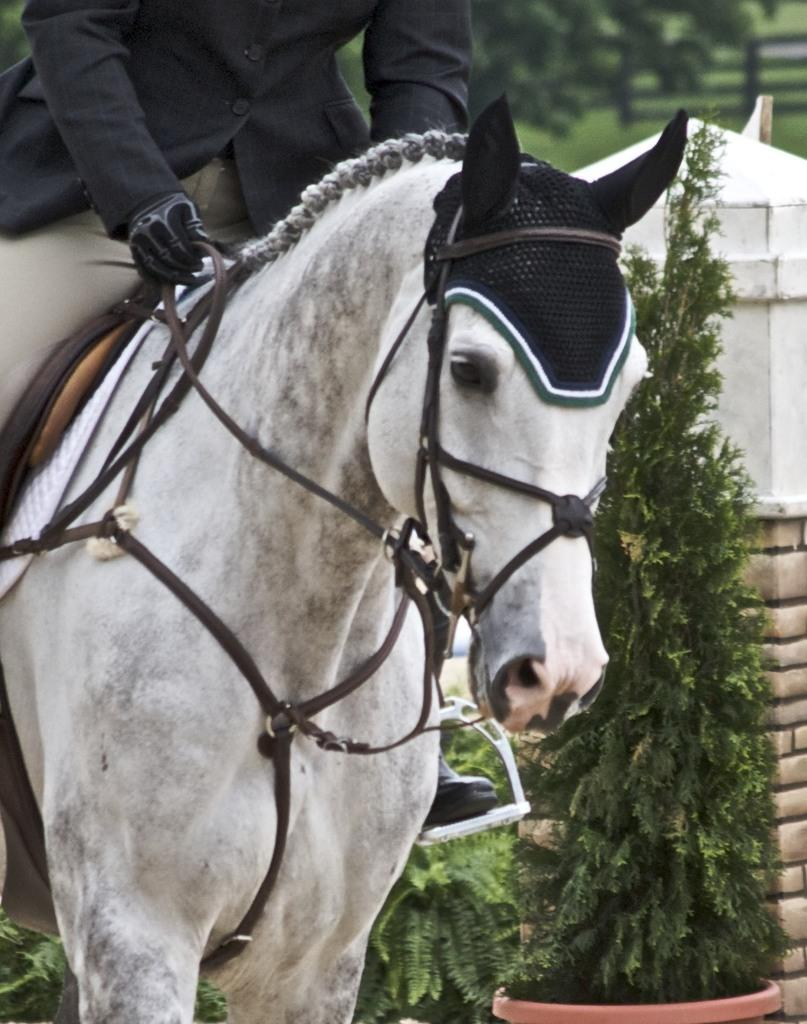Who is present in the image? There is a man in the image. What is the man wearing? The man is wearing a black jacket. What is the man doing in the image? The man is sitting on a white horse. What can be seen in the background of the image? There are plants and a wall in the image. What type of ghost can be seen interacting with the man in the image? There is no ghost present in the image; it features a man sitting on a white horse with plants and a wall in the background. 